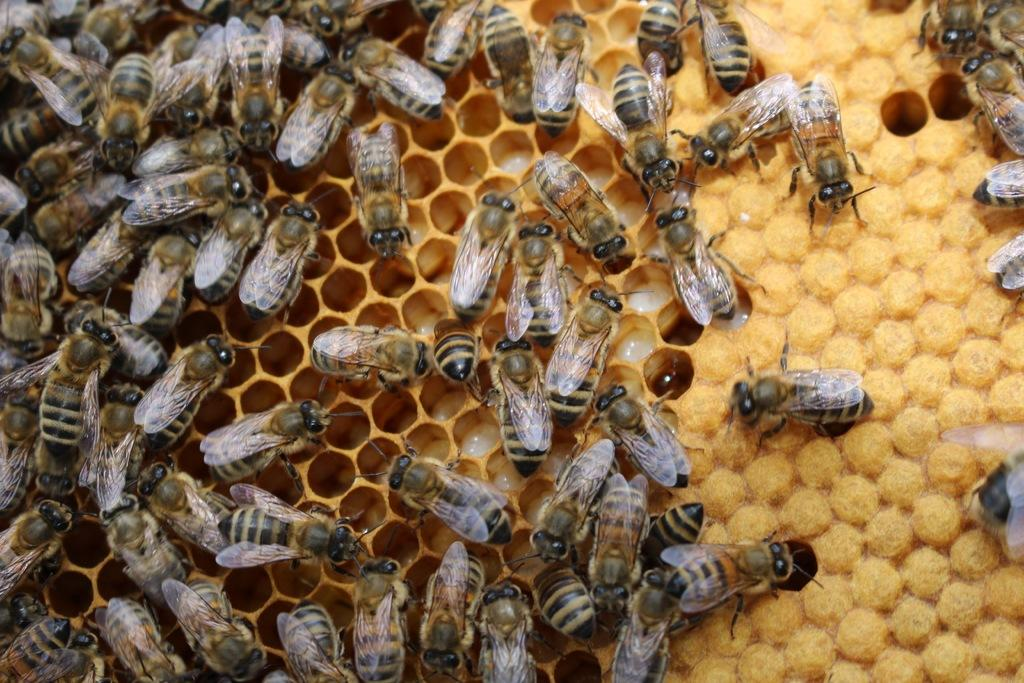What is the main subject of the image? The main subject of the image is a honeycomb. Are there any living organisms visible in the image? Yes, honey bees are present in the image. What type of pencil can be seen in the image? There is no pencil present in the image. What time of day is depicted in the image? The time of day is not mentioned or depicted in the image. 